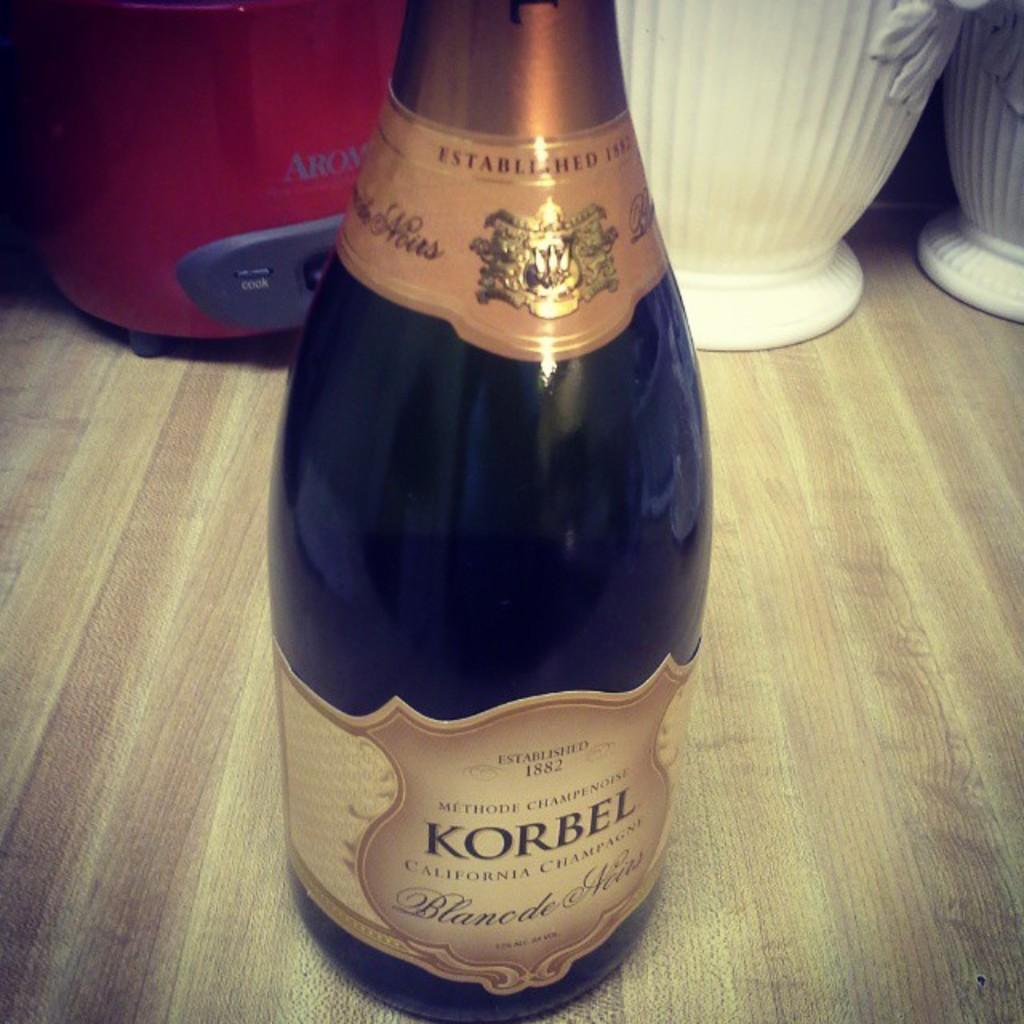<image>
Provide a brief description of the given image. a bottle of wine called korbel placed on the counter 